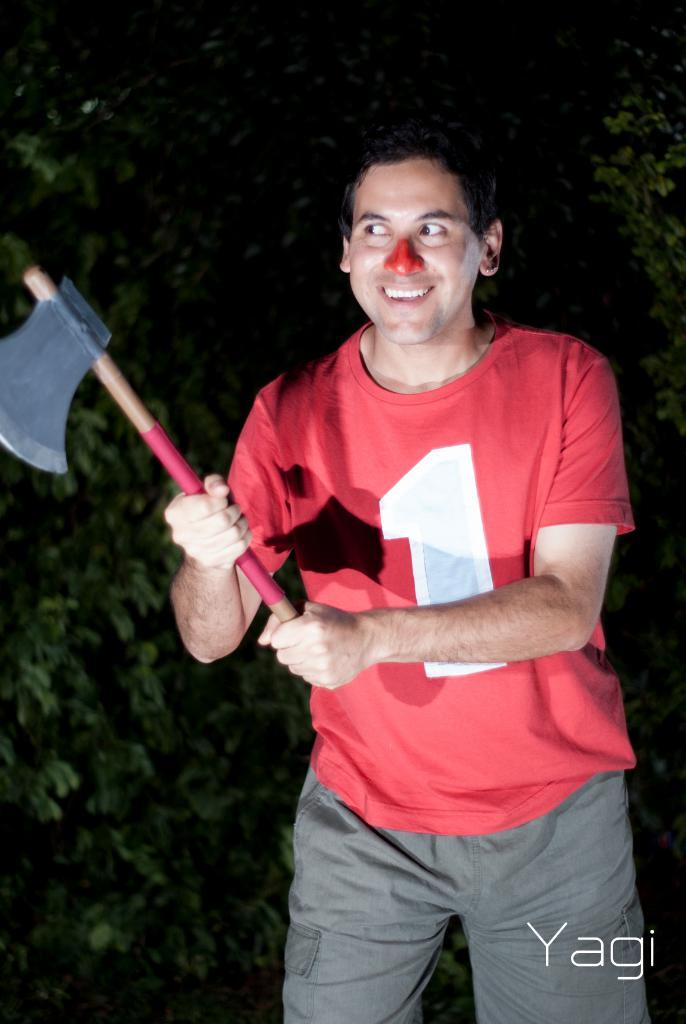What is the main subject of the picture? The main subject of the picture is a man. What is the man doing in the image? The man is catching an axe in the image. What is the man's posture in the image? The man is standing in the image. Can you describe the background of the image? There may be trees present in the background of the image. What type of feeling can be seen on the man's face in the image? The image does not provide information about the man's facial expression or feelings. Can you describe the sea visible in the image? There is no sea present in the image; it features a man catching an axe. 